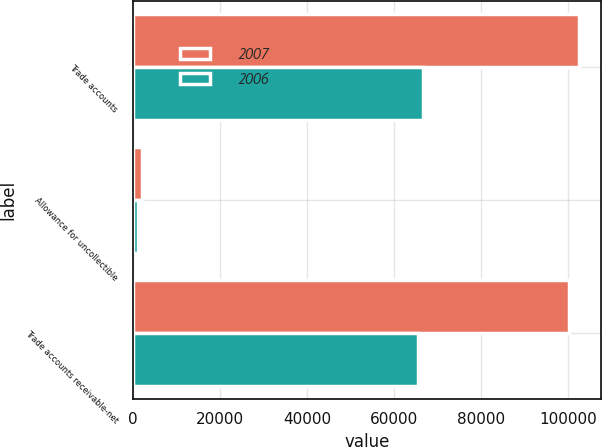Convert chart. <chart><loc_0><loc_0><loc_500><loc_500><stacked_bar_chart><ecel><fcel>Trade accounts<fcel>Allowance for uncollectible<fcel>Trade accounts receivable-net<nl><fcel>2007<fcel>102317<fcel>2223<fcel>100094<nl><fcel>2006<fcel>66728<fcel>1160<fcel>65568<nl></chart> 